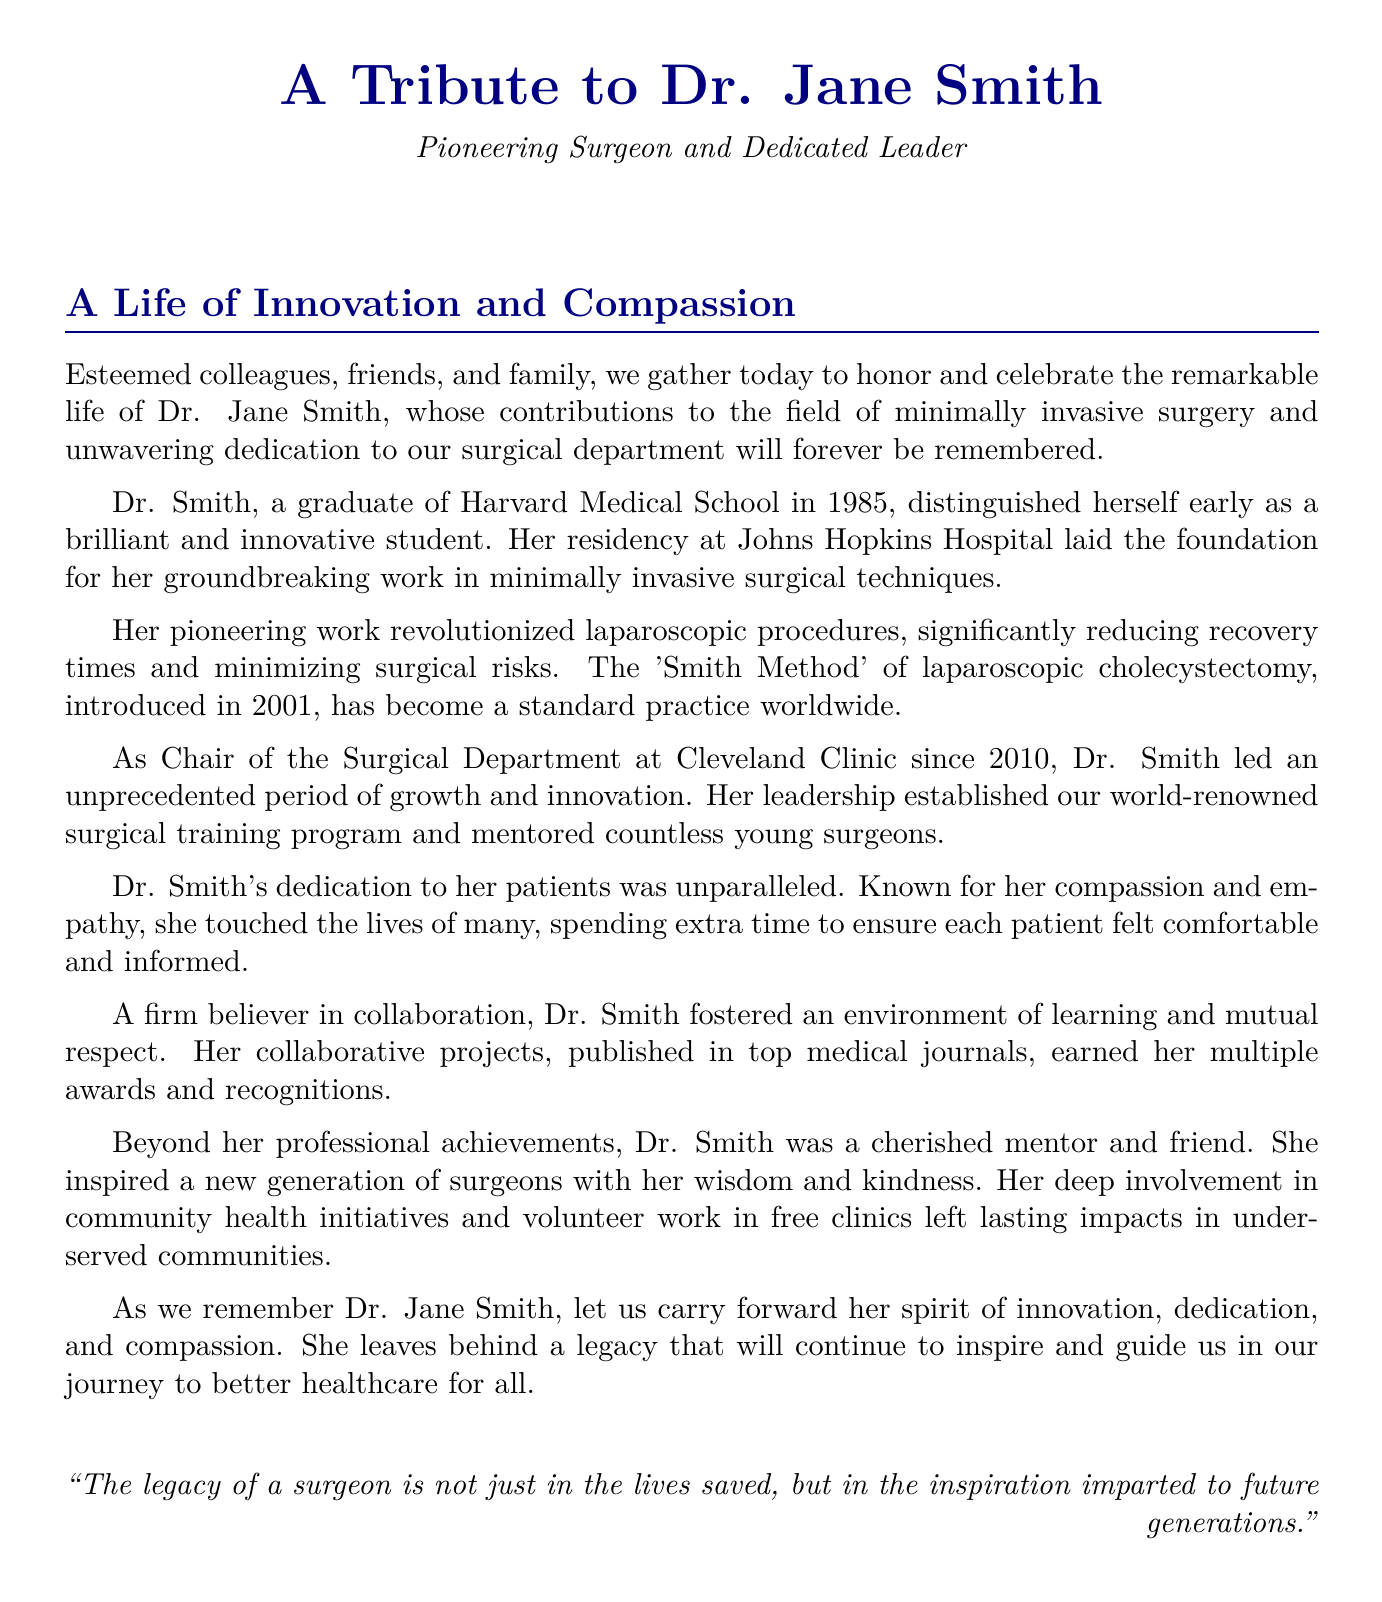What is the full name of the honoree? The document refers to the honoree as Dr. Jane Smith.
Answer: Dr. Jane Smith What year did Dr. Jane Smith graduate from Harvard Medical School? The document states Dr. Smith graduated in 1985.
Answer: 1985 What is the name of the surgical method introduced by Dr. Smith in 2001? The document mentions the 'Smith Method' of laparoscopic cholecystectomy.
Answer: Smith Method In what year did Dr. Smith become Chair of the Surgical Department at Cleveland Clinic? The document specifies that she became Chair in 2010.
Answer: 2010 What characteristic of Dr. Smith's patient care is highlighted in the document? The document mentions her compassion and empathy towards patients.
Answer: Compassion and empathy What impact did Dr. Smith have on the surgical training program? The document states she established a world-renowned surgical training program.
Answer: Established world-renowned surgical training program What kind of projects did Dr. Smith foster in her department? The document indicates she fostered collaborative projects.
Answer: Collaborative projects What type of initiatives was Dr. Smith involved in beyond her professional achievements? The document highlights her involvement in community health initiatives.
Answer: Community health initiatives 